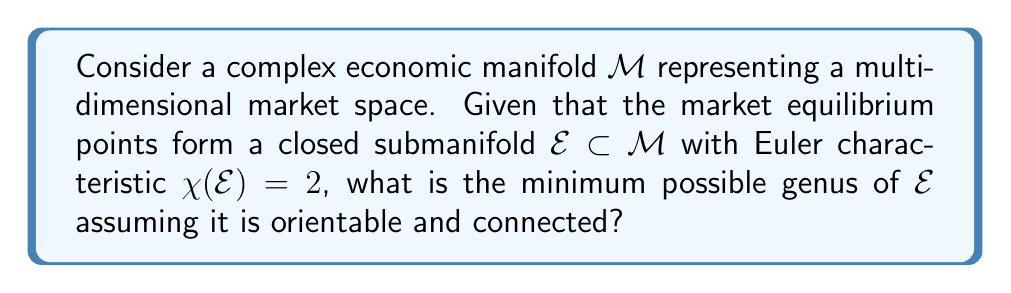Show me your answer to this math problem. To solve this problem, we'll follow these steps:

1) Recall the relationship between Euler characteristic $\chi$, genus $g$, and the number of connected components $n$ for an orientable surface:

   $$\chi = 2n - 2g$$

2) We're given that $\chi(\mathcal{E}) = 2$ and that $\mathcal{E}$ is connected, so $n = 1$:

   $$2 = 2(1) - 2g$$

3) Simplify the equation:

   $$2 = 2 - 2g$$

4) Subtract 2 from both sides:

   $$0 = -2g$$

5) Divide both sides by -2:

   $$g = 0$$

6) Since genus must be a non-negative integer, the minimum possible genus is 0.

This result implies that the market equilibrium submanifold $\mathcal{E}$ is topologically equivalent to a sphere, which contradicts simplistic populist economic models that often assume linear or planar market structures.
Answer: 0 